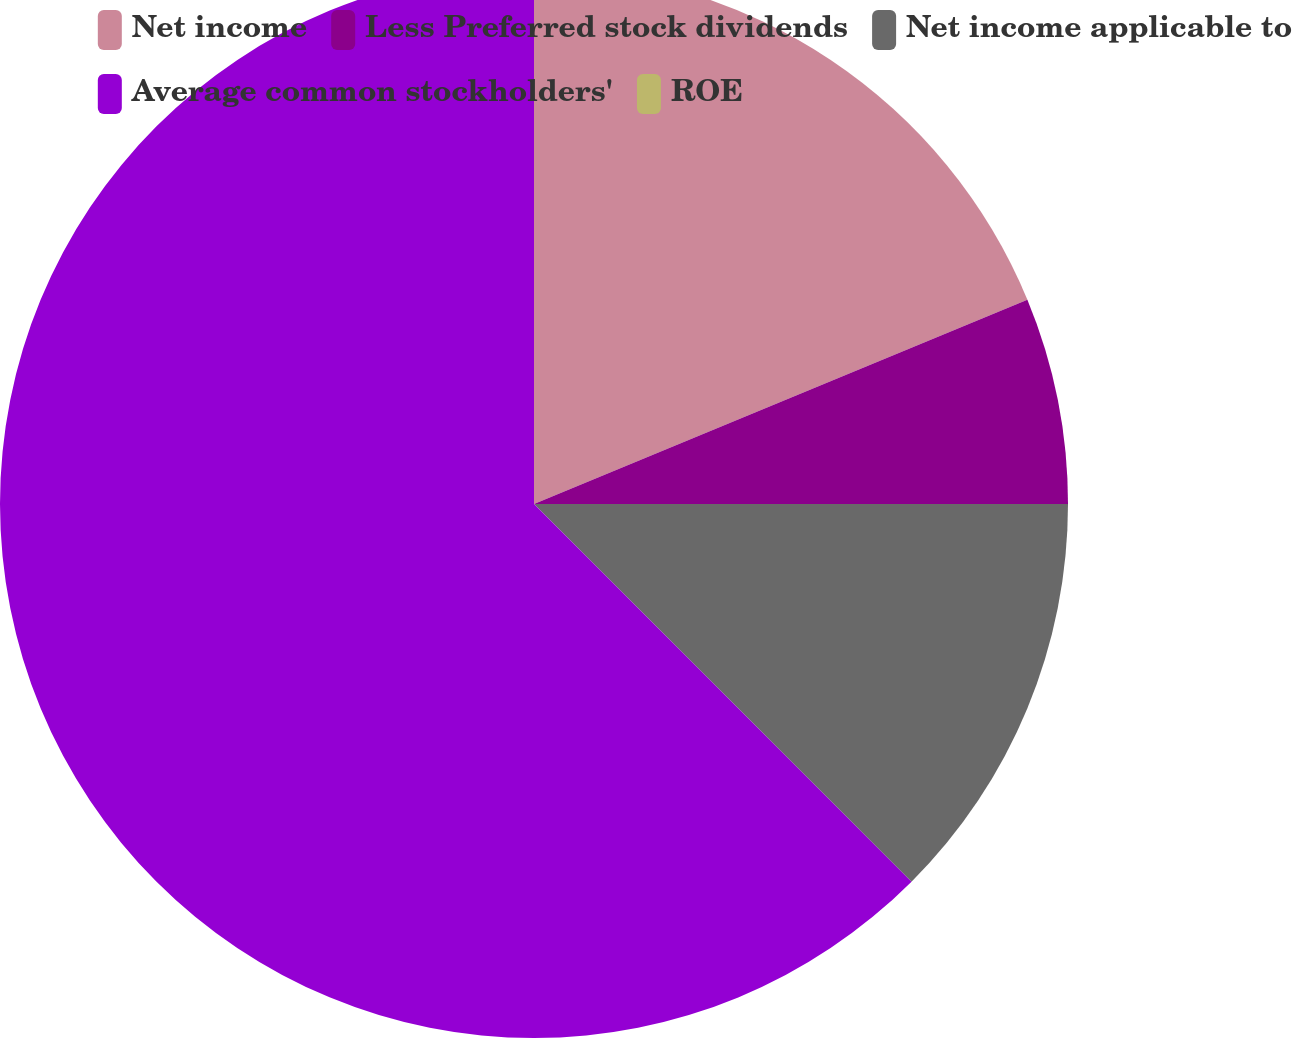Convert chart. <chart><loc_0><loc_0><loc_500><loc_500><pie_chart><fcel>Net income<fcel>Less Preferred stock dividends<fcel>Net income applicable to<fcel>Average common stockholders'<fcel>ROE<nl><fcel>18.75%<fcel>6.25%<fcel>12.5%<fcel>62.49%<fcel>0.0%<nl></chart> 